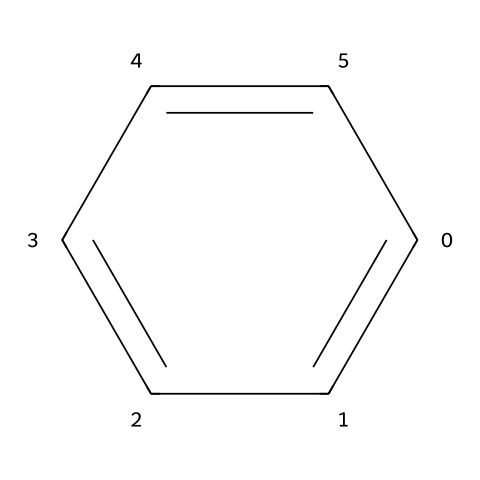How many carbon atoms are in benzene? The SMILES representation shows that benzene consists of a cyclic structure where the 'c' indicates a carbon atom. Since there are six 'c' characters in the SMILES, it indicates that there are six carbon atoms in total.
Answer: six What is the number of hydrogen atoms in benzene? Each carbon atom in benzene forms bonds with one hydrogen atom. There are six carbon atoms, so there are also six hydrogen atoms bonded to those carbons in benzene.
Answer: six What type of bonding is present in benzene? The structure of benzene shows alternating single and double bonds between carbon atoms, which is indicative of resonance in aromatic compounds. Therefore, the bonding can be described as delocalized pi-bonding due to the resonance structure.
Answer: delocalized What is the hybridization of the carbon atoms in benzene? Each carbon atom in benzene is bonded to three other atoms (two adjacent carbon atoms and one hydrogen atom), which corresponds to sp2 hybridization due to the presence of one unhybridized p-orbital participating in the aromatic π-system.
Answer: sp2 Is benzene an aromatic compound? The presence of a cyclic structure with conjugated double bonds and delocalized electrons, fitting Huckel's rule (4n + 2 π electrons, where n=1), confirms that benzene is classified as an aromatic compound.
Answer: yes What is the molecular formula of benzene? By counting the atoms represented in the SMILES notation, benzene consists of six carbon atoms and six hydrogen atoms, leading to the molecular formula C6H6.
Answer: C6H6 